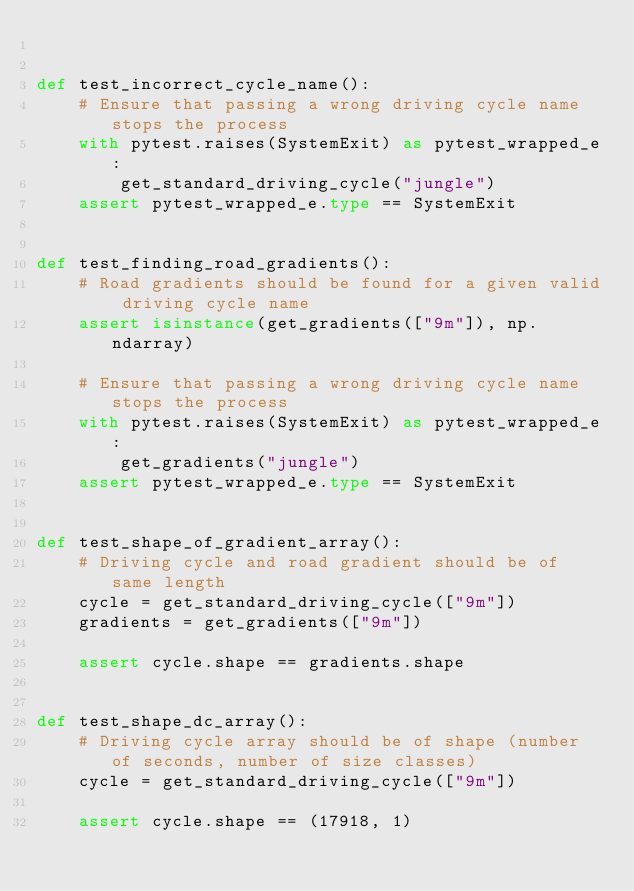<code> <loc_0><loc_0><loc_500><loc_500><_Python_>

def test_incorrect_cycle_name():
    # Ensure that passing a wrong driving cycle name stops the process
    with pytest.raises(SystemExit) as pytest_wrapped_e:
        get_standard_driving_cycle("jungle")
    assert pytest_wrapped_e.type == SystemExit


def test_finding_road_gradients():
    # Road gradients should be found for a given valid driving cycle name
    assert isinstance(get_gradients(["9m"]), np.ndarray)

    # Ensure that passing a wrong driving cycle name stops the process
    with pytest.raises(SystemExit) as pytest_wrapped_e:
        get_gradients("jungle")
    assert pytest_wrapped_e.type == SystemExit


def test_shape_of_gradient_array():
    # Driving cycle and road gradient should be of same length
    cycle = get_standard_driving_cycle(["9m"])
    gradients = get_gradients(["9m"])

    assert cycle.shape == gradients.shape


def test_shape_dc_array():
    # Driving cycle array should be of shape (number of seconds, number of size classes)
    cycle = get_standard_driving_cycle(["9m"])

    assert cycle.shape == (17918, 1)
</code> 